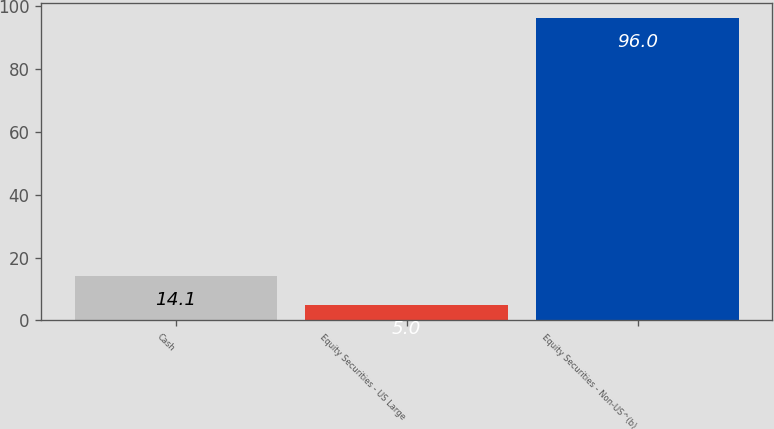<chart> <loc_0><loc_0><loc_500><loc_500><bar_chart><fcel>Cash<fcel>Equity Securities - US Large<fcel>Equity Securities - Non-US^(b)<nl><fcel>14.1<fcel>5<fcel>96<nl></chart> 